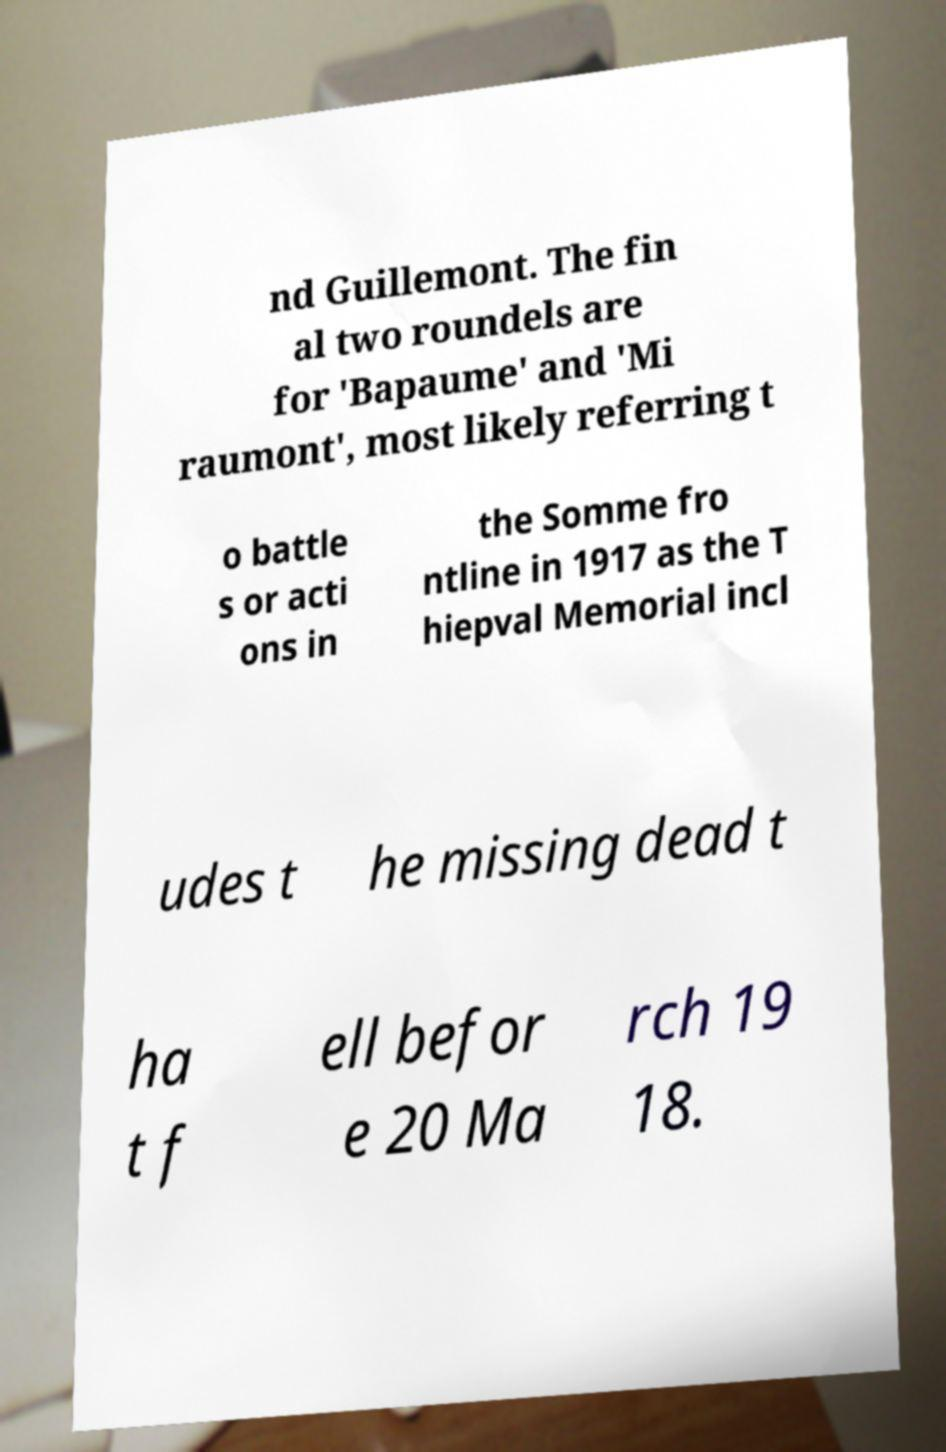There's text embedded in this image that I need extracted. Can you transcribe it verbatim? nd Guillemont. The fin al two roundels are for 'Bapaume' and 'Mi raumont', most likely referring t o battle s or acti ons in the Somme fro ntline in 1917 as the T hiepval Memorial incl udes t he missing dead t ha t f ell befor e 20 Ma rch 19 18. 